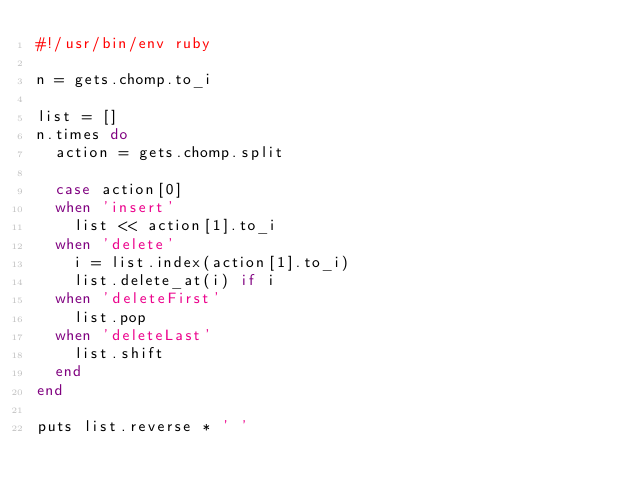<code> <loc_0><loc_0><loc_500><loc_500><_Ruby_>#!/usr/bin/env ruby

n = gets.chomp.to_i

list = []
n.times do
  action = gets.chomp.split

  case action[0]
  when 'insert'
    list << action[1].to_i
  when 'delete'
    i = list.index(action[1].to_i)
    list.delete_at(i) if i
  when 'deleteFirst'
    list.pop
  when 'deleteLast'
    list.shift
  end
end

puts list.reverse * ' '</code> 